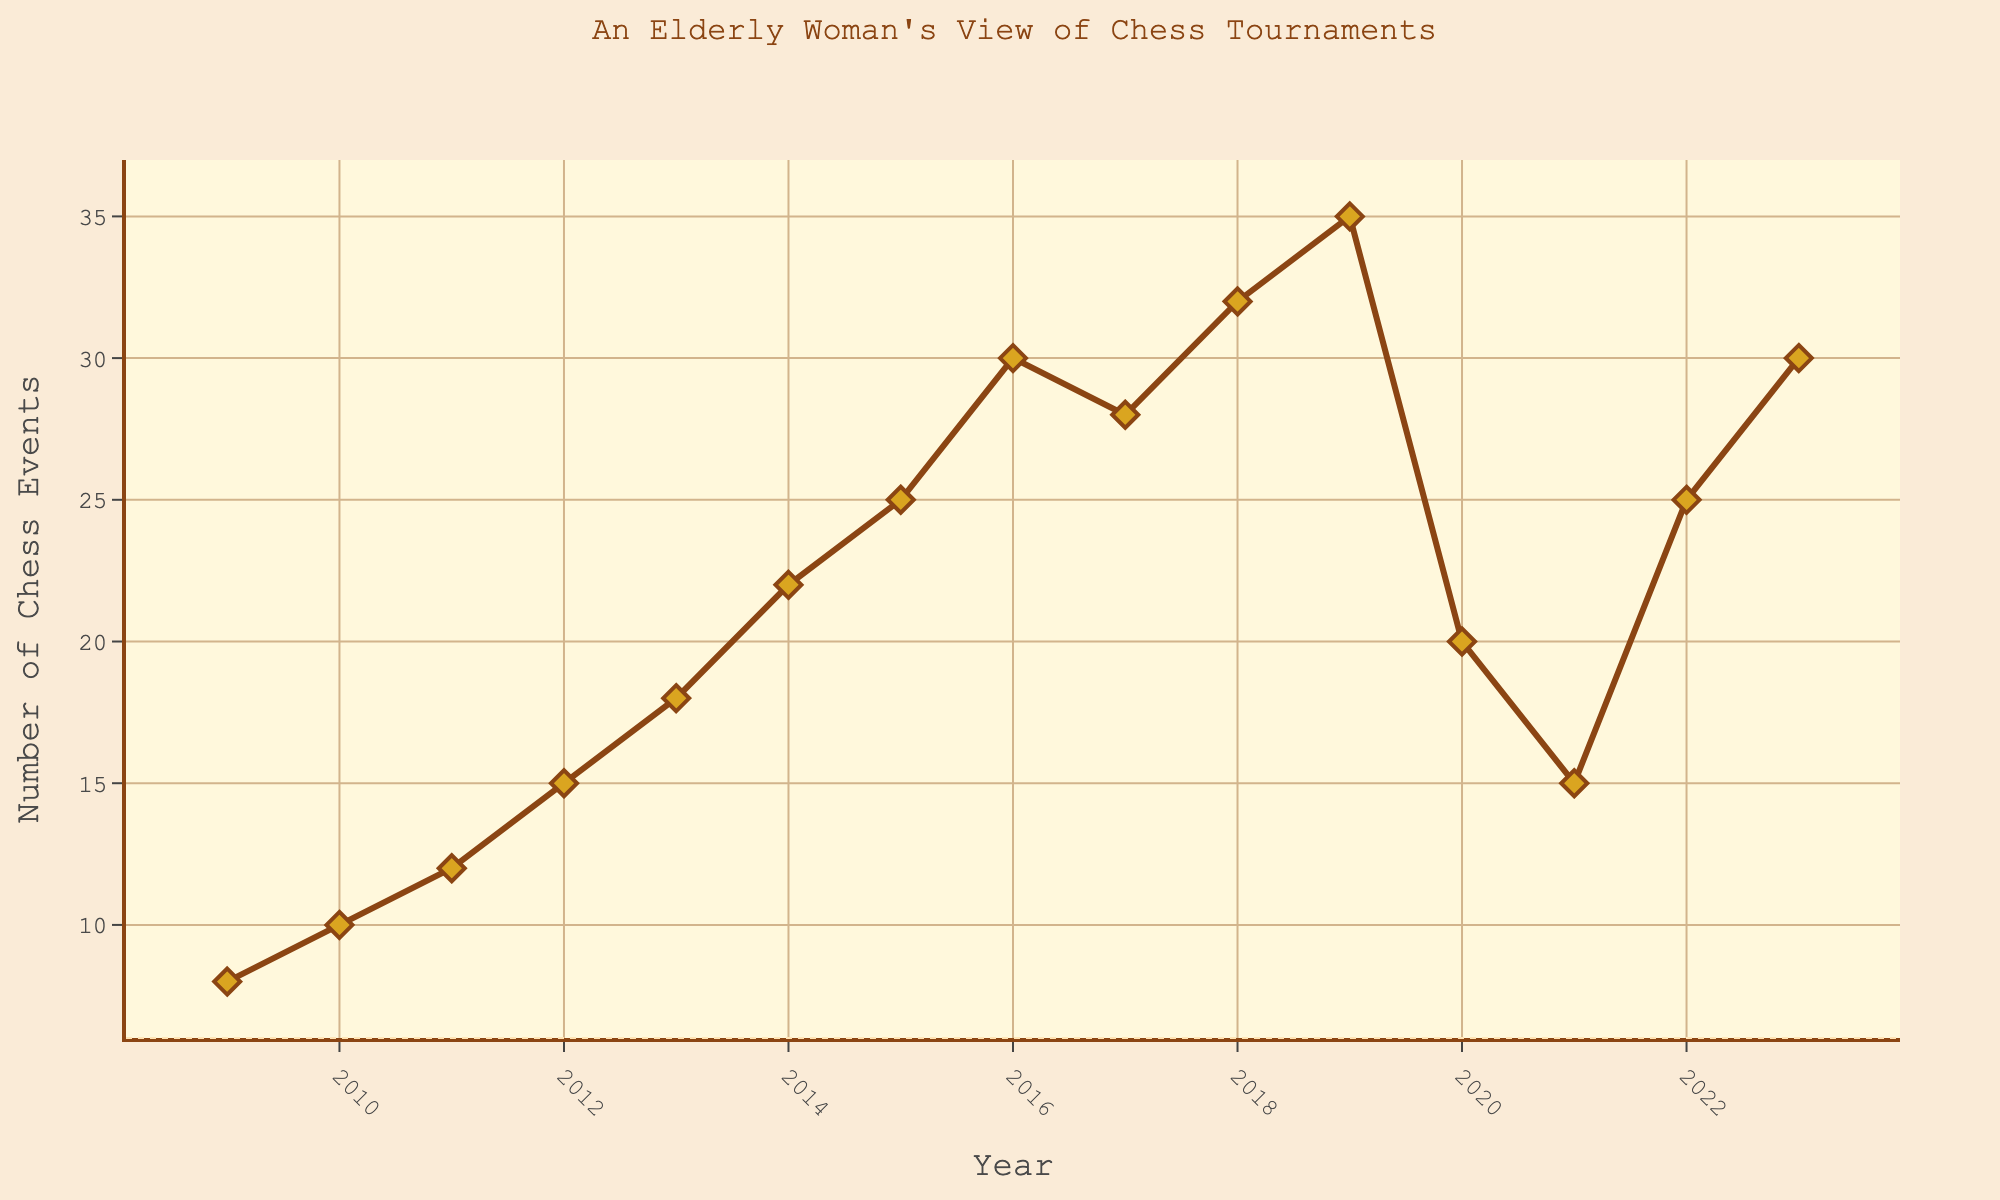What is the trend in the number of chess events from 2009 to 2019? The number of chess events increases almost every year from 2009 to 2019. It starts at 8 events in 2009 and reaches 35 events in 2019.
Answer: Increasing How many more chess events were held in 2019 compared to 2009? In 2009, there were 8 events, and in 2019, there were 35 events. The difference is 35 - 8 = 27 more events.
Answer: 27 In which years did the number of chess events decrease compared to the previous year? From 2016 to 2017, the number of events decreased from 30 to 28. From 2019 to 2020, it decreased from 35 to 20, and from 2020 to 2021, it decreased from 20 to 15.
Answer: 2017, 2020, 2021 What is the average number of chess events held from 2009 to 2023? Add up all the events from 2009 to 2023 and divide by the number of years (15). Sum = 8 + 10 + 12 + 15 + 18 + 22 + 25 + 30 + 28 + 32 + 35 + 20 + 15 + 25 + 30 = 325. Average = 325 / 15 = 21.67.
Answer: 21.67 Which year had the highest number of chess events? By inspecting the plot, 2019 had the highest number of chess events at 35.
Answer: 2019 What is the largest increase in the number of chess events from one year to the next? The largest increase is from 2021 to 2022, which is 25 - 15 = 10 events.
Answer: 10 Which year had the lowest number of chess events, and how many were there? Inspecting the plot, 2009 had the lowest number of chess events with 8 events.
Answer: 2009, 8 How did the number of chess events change from 2021 to 2023? From 2021 to 2022, the number increased from 15 to 25, and from 2022 to 2023, it increased from 25 to 30.
Answer: Increased What was the number of chess events in 2017, and how did it compare to 2016? In 2017, there were 28 events, which is 2 fewer than the 30 events in 2016.
Answer: 28; 2 fewer What is the median number of chess events from 2009 to 2023? List all the numbers in order and find the middle value. The median is the 8th value in the ordered list: 8, 10, 12, 15, 15, 18, 20, 22, 25, 25, 28, 30, 30, 32, 35. The median value is 22.
Answer: 22 